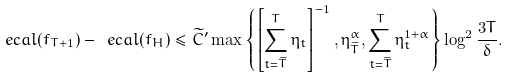Convert formula to latex. <formula><loc_0><loc_0><loc_500><loc_500>\ e c a l ( f _ { T + 1 } ) - \ e c a l ( f _ { H } ) \leq \widetilde { C } ^ { \prime } \max \left \{ \left [ \sum _ { t = \widetilde { T } } ^ { T } \eta _ { t } \right ] ^ { - 1 } , \eta _ { \widetilde { T } } ^ { \alpha } , \sum _ { t = \widetilde { T } } ^ { T } \eta _ { t } ^ { 1 + \alpha } \right \} \log ^ { 2 } \frac { 3 T } { \delta } .</formula> 